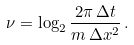<formula> <loc_0><loc_0><loc_500><loc_500>\nu = \log _ { 2 } \frac { 2 \pi \, \Delta t } { m \, \Delta x ^ { 2 } } \, .</formula> 